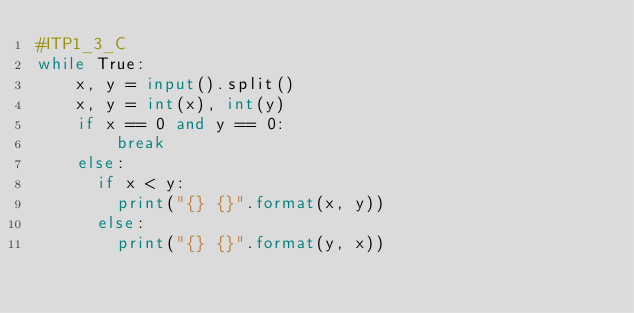Convert code to text. <code><loc_0><loc_0><loc_500><loc_500><_Python_>#ITP1_3_C
while True:
    x, y = input().split()
    x, y = int(x), int(y)
    if x == 0 and y == 0:
        break
    else:
      if x < y:
        print("{} {}".format(x, y))
      else:
        print("{} {}".format(y, x))
</code> 